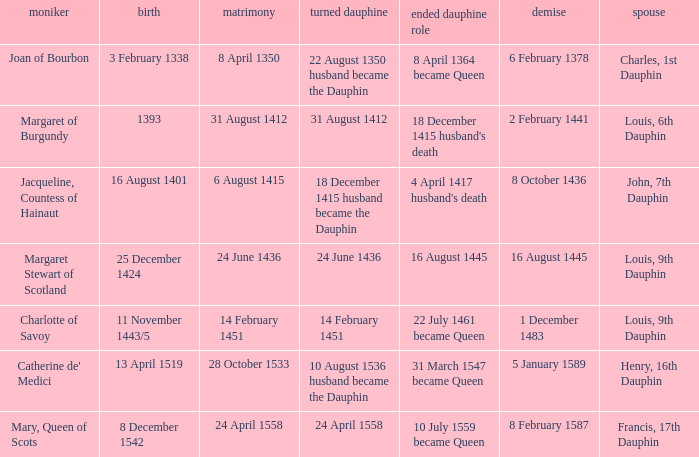When was became dauphine when birth is 1393? 31 August 1412. 